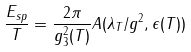<formula> <loc_0><loc_0><loc_500><loc_500>\frac { E _ { s p } } { T } = \frac { 2 \pi } { g ^ { 2 } _ { 3 } ( T ) } A ( \lambda _ { T } / g ^ { 2 } , \epsilon ( T ) )</formula> 